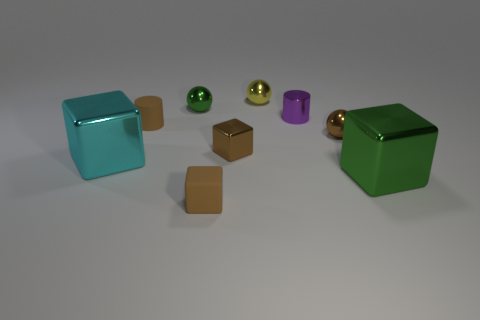Subtract all red blocks. Subtract all red cylinders. How many blocks are left? 4 Subtract all cylinders. How many objects are left? 7 Subtract all small green shiny balls. Subtract all tiny matte cubes. How many objects are left? 7 Add 1 small brown metal spheres. How many small brown metal spheres are left? 2 Add 1 brown spheres. How many brown spheres exist? 2 Subtract 0 cyan cylinders. How many objects are left? 9 